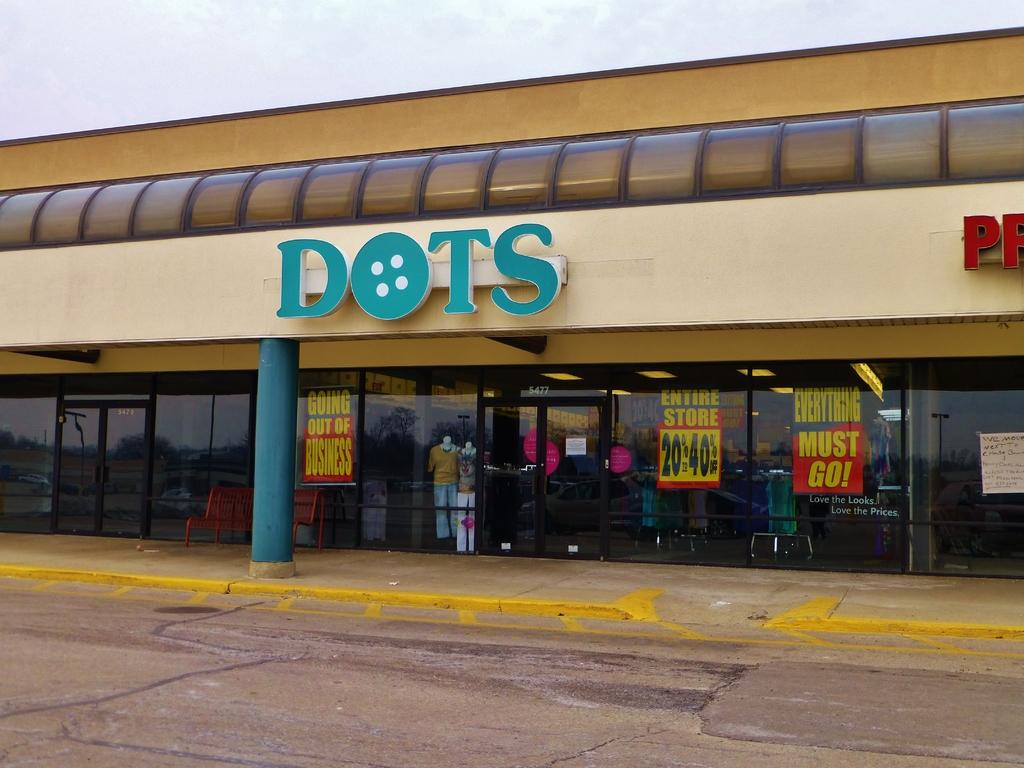What type of structure is visible in the image? There is a building in the image. What can be seen on the building in the image? There are name boards in the image. What other objects are present in the image? There are mannequins, posters, a bench, and various reflections, including vehicles, poles, lights, trees, and the sky. Can you tell me how many shoes are on the mannequins in the image? There is no information about shoes on the mannequins in the image, so it cannot be determined. What type of discovery was made by the person in the image? There is no person or discovery mentioned in the image, so it cannot be answered. 